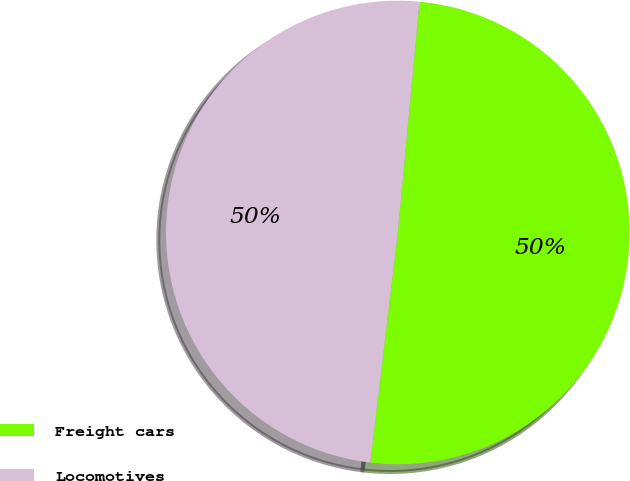<chart> <loc_0><loc_0><loc_500><loc_500><pie_chart><fcel>Freight cars<fcel>Locomotives<nl><fcel>50.4%<fcel>49.6%<nl></chart> 